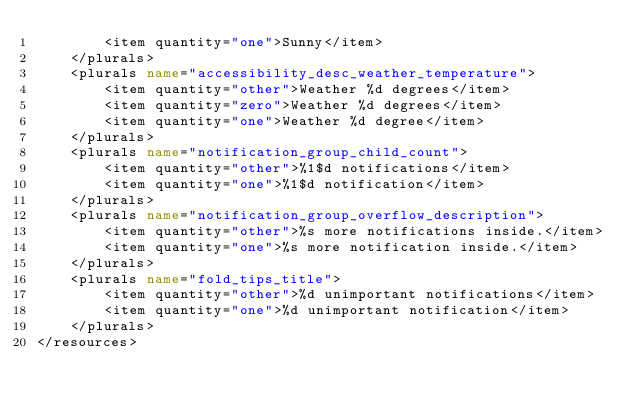<code> <loc_0><loc_0><loc_500><loc_500><_XML_>        <item quantity="one">Sunny</item>
    </plurals>
    <plurals name="accessibility_desc_weather_temperature">
        <item quantity="other">Weather %d degrees</item>
        <item quantity="zero">Weather %d degrees</item>
        <item quantity="one">Weather %d degree</item>
    </plurals>
    <plurals name="notification_group_child_count">
        <item quantity="other">%1$d notifications</item>
        <item quantity="one">%1$d notification</item>
    </plurals>
    <plurals name="notification_group_overflow_description">
        <item quantity="other">%s more notifications inside.</item>
        <item quantity="one">%s more notification inside.</item>
    </plurals>
    <plurals name="fold_tips_title">
        <item quantity="other">%d unimportant notifications</item>
        <item quantity="one">%d unimportant notification</item>
    </plurals>
</resources>
</code> 